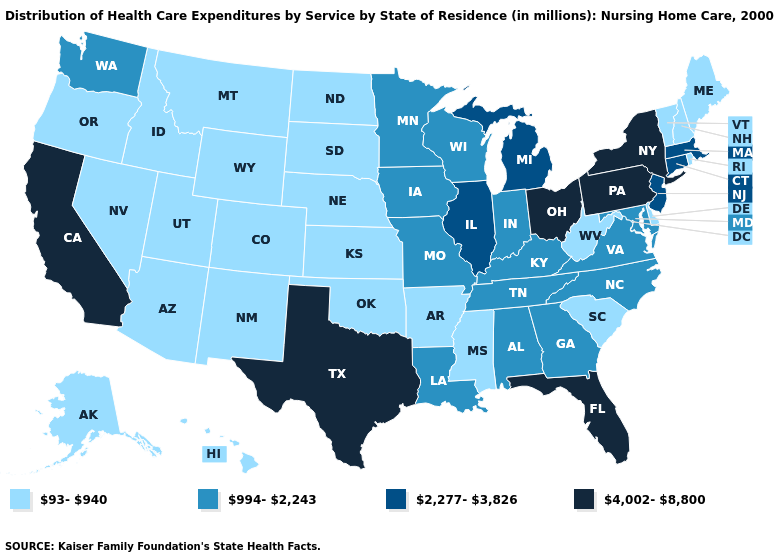What is the lowest value in the USA?
Keep it brief. 93-940. What is the highest value in the USA?
Short answer required. 4,002-8,800. Does Delaware have the lowest value in the South?
Be succinct. Yes. What is the highest value in states that border Vermont?
Concise answer only. 4,002-8,800. Name the states that have a value in the range 93-940?
Quick response, please. Alaska, Arizona, Arkansas, Colorado, Delaware, Hawaii, Idaho, Kansas, Maine, Mississippi, Montana, Nebraska, Nevada, New Hampshire, New Mexico, North Dakota, Oklahoma, Oregon, Rhode Island, South Carolina, South Dakota, Utah, Vermont, West Virginia, Wyoming. Name the states that have a value in the range 4,002-8,800?
Give a very brief answer. California, Florida, New York, Ohio, Pennsylvania, Texas. What is the lowest value in the South?
Keep it brief. 93-940. Which states have the lowest value in the Northeast?
Keep it brief. Maine, New Hampshire, Rhode Island, Vermont. Does Vermont have a lower value than Nevada?
Write a very short answer. No. What is the lowest value in the South?
Concise answer only. 93-940. Does Kansas have the lowest value in the USA?
Write a very short answer. Yes. What is the highest value in the MidWest ?
Give a very brief answer. 4,002-8,800. Name the states that have a value in the range 4,002-8,800?
Write a very short answer. California, Florida, New York, Ohio, Pennsylvania, Texas. What is the highest value in states that border Connecticut?
Give a very brief answer. 4,002-8,800. 